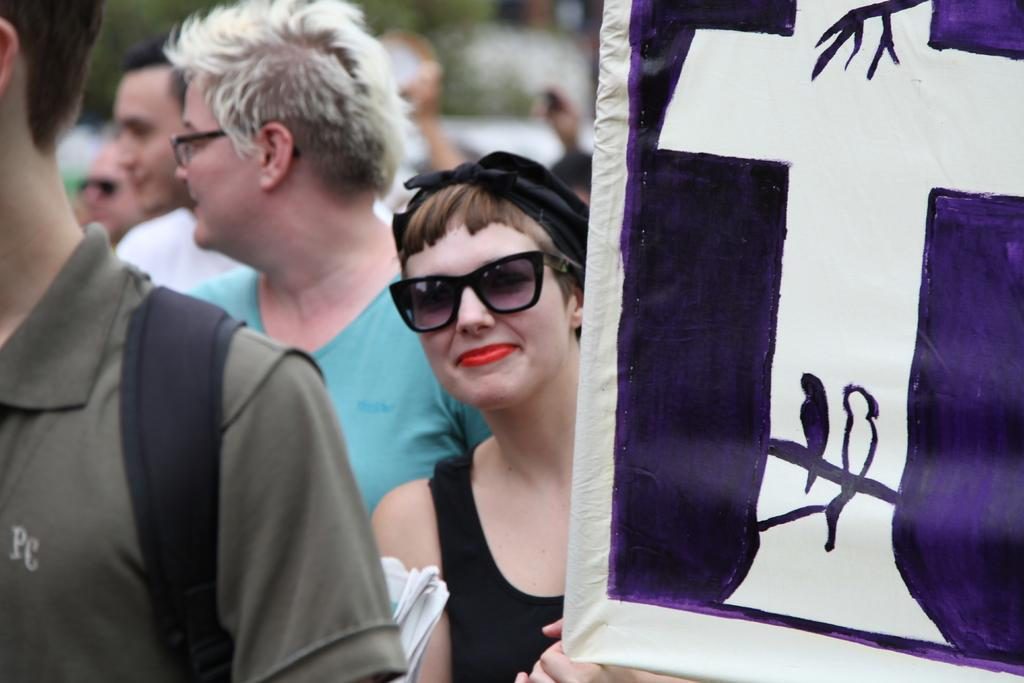What can be seen in the image involving multiple individuals? There is a group of people in the image. What additional element is present in the image? There is a banner in the image. How would you describe the background of the image? The background of the image is blurry. How many properties do the sisters own in the image? There is no mention of properties or sisters in the image, so this information cannot be determined. 